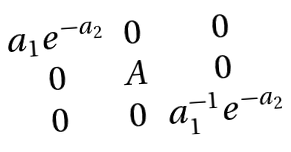<formula> <loc_0><loc_0><loc_500><loc_500>\begin{matrix} a _ { 1 } e ^ { - a _ { 2 } } & 0 & 0 \\ 0 & A & 0 \\ 0 & 0 & a _ { 1 } ^ { - 1 } e ^ { - a _ { 2 } } \end{matrix}</formula> 